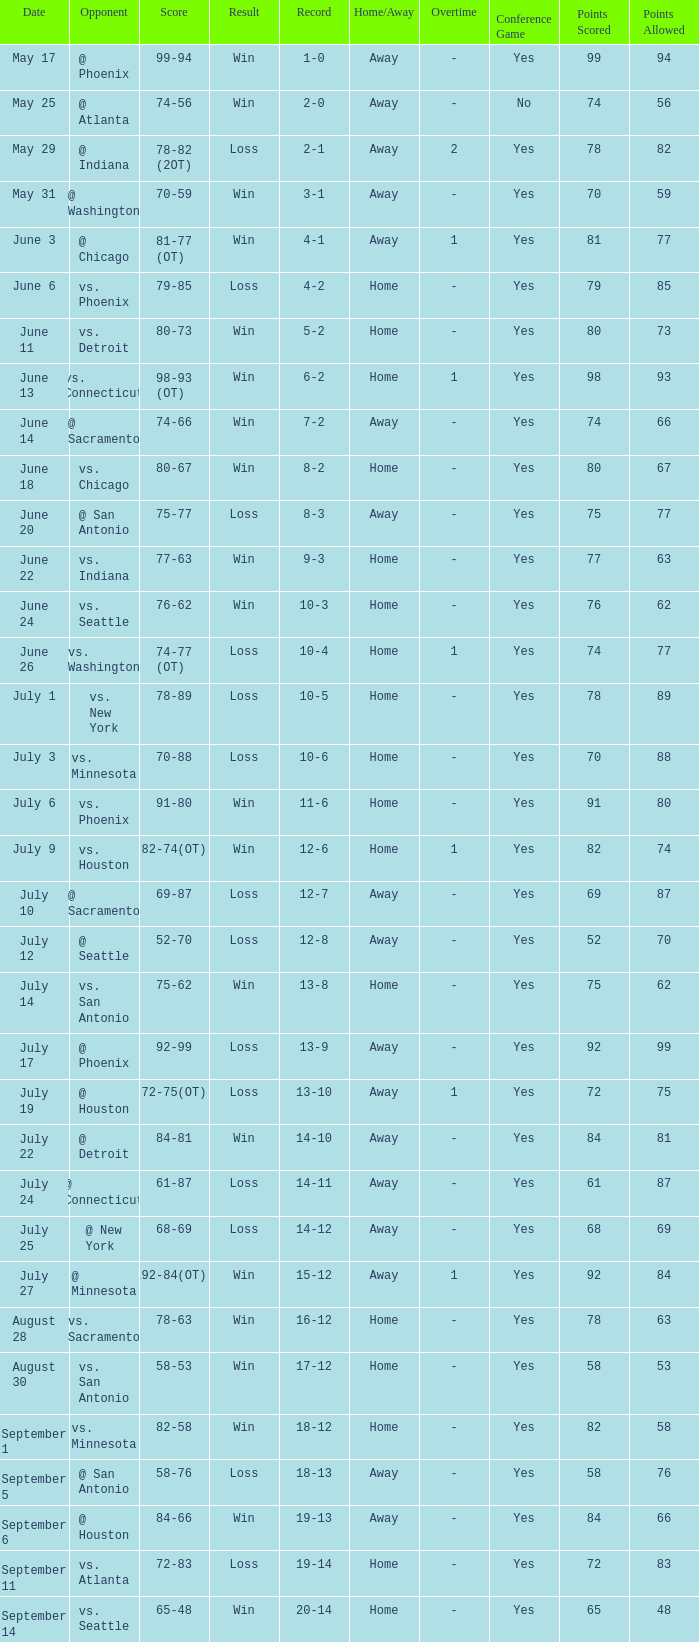What is the Record of the game on September 6? 19-13. 